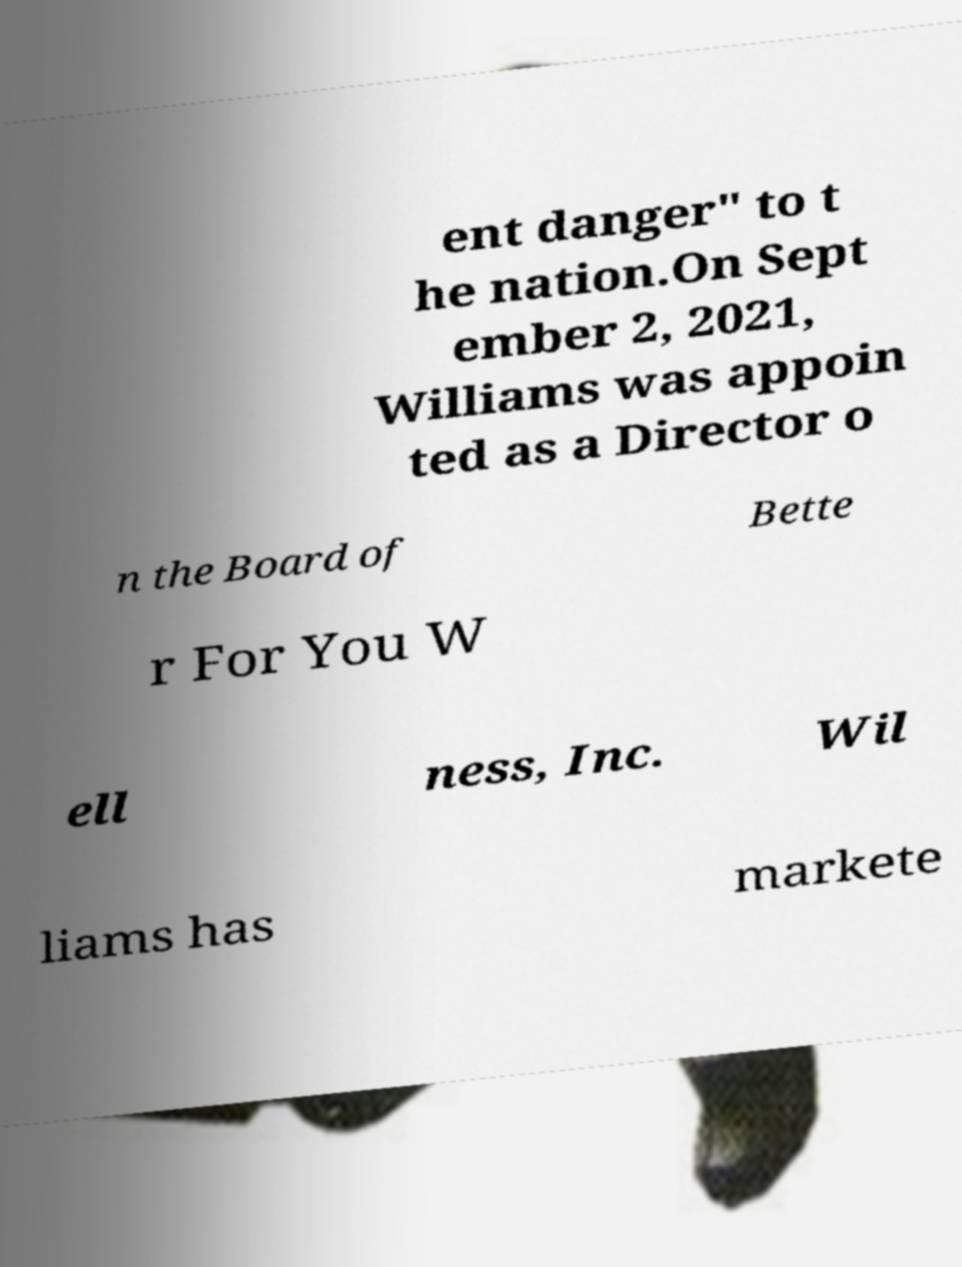Could you assist in decoding the text presented in this image and type it out clearly? ent danger" to t he nation.On Sept ember 2, 2021, Williams was appoin ted as a Director o n the Board of Bette r For You W ell ness, Inc. Wil liams has markete 